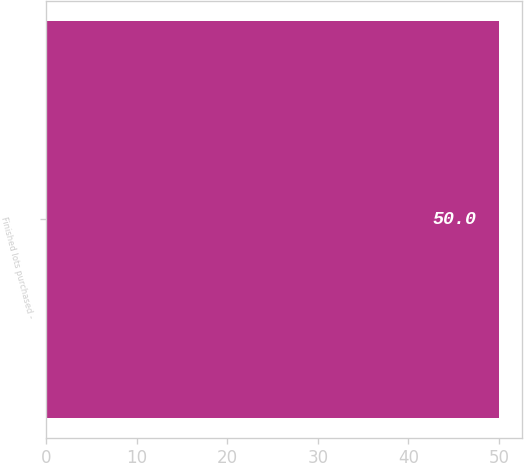<chart> <loc_0><loc_0><loc_500><loc_500><bar_chart><fcel>Finished lots purchased -<nl><fcel>50<nl></chart> 